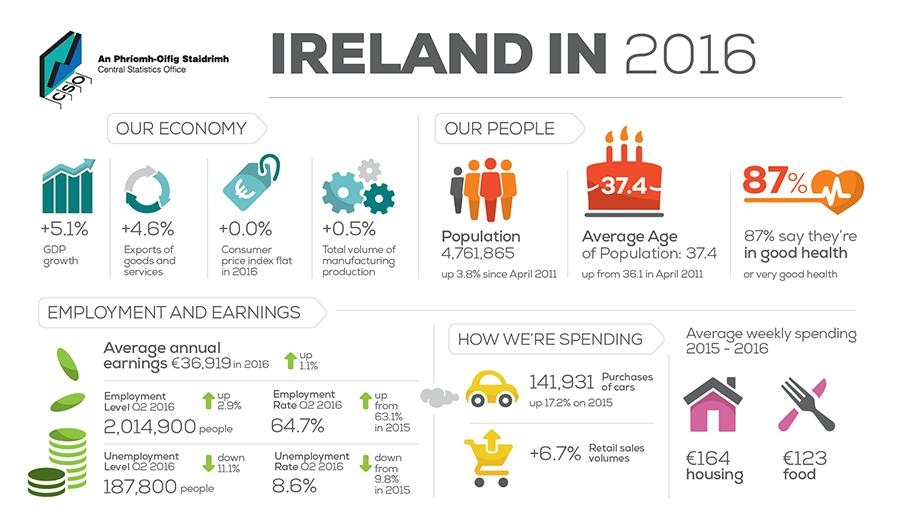Identify some key points in this picture. According to a recent survey, approximately 13% of individuals reported being in poor health. The employment rate is 64.7%. There are four people icons present in this infographic. The unemployment rate is 8.6%. 